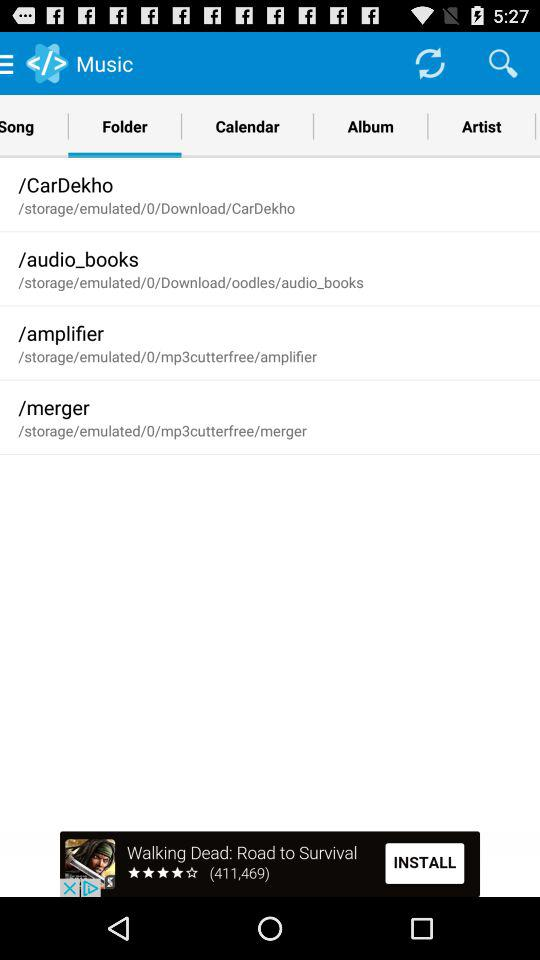What is the selected tab? The selected tab is "Folder". 